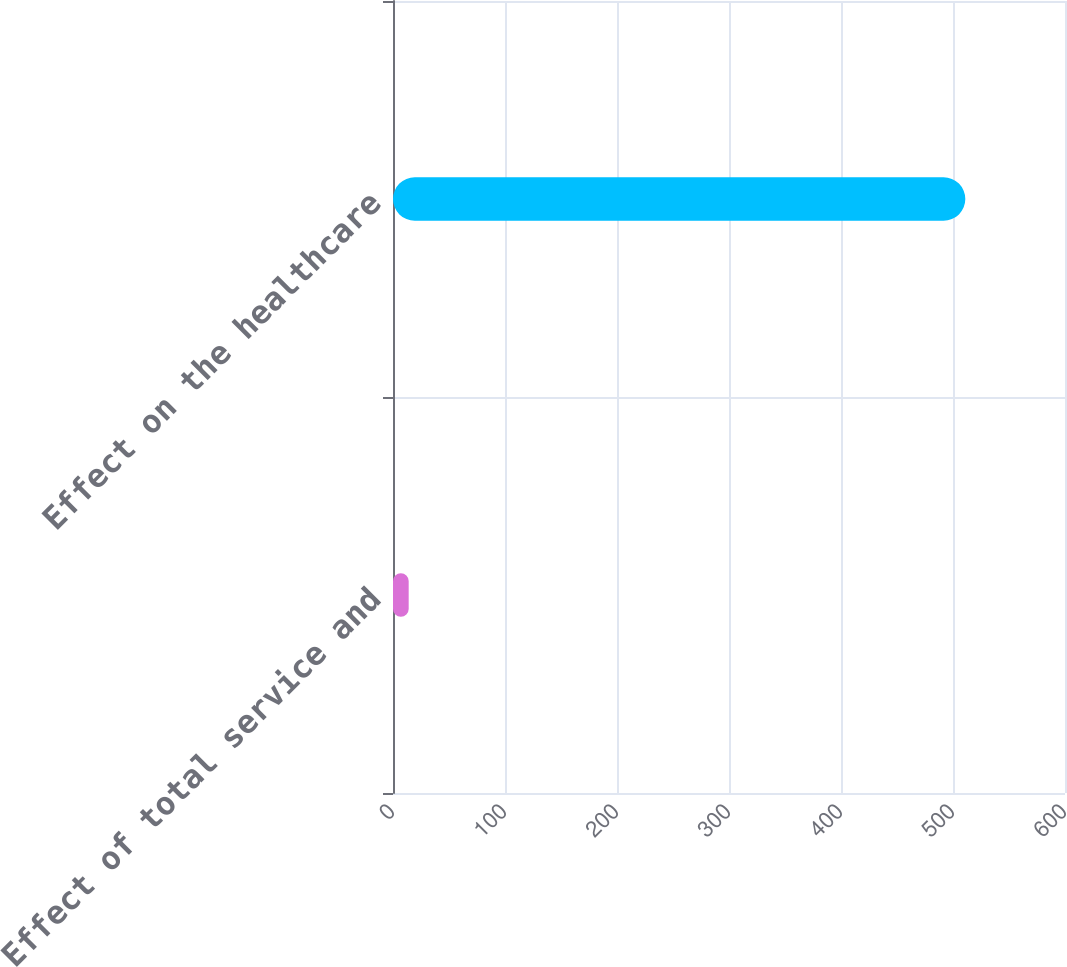Convert chart. <chart><loc_0><loc_0><loc_500><loc_500><bar_chart><fcel>Effect of total service and<fcel>Effect on the healthcare<nl><fcel>14<fcel>511<nl></chart> 